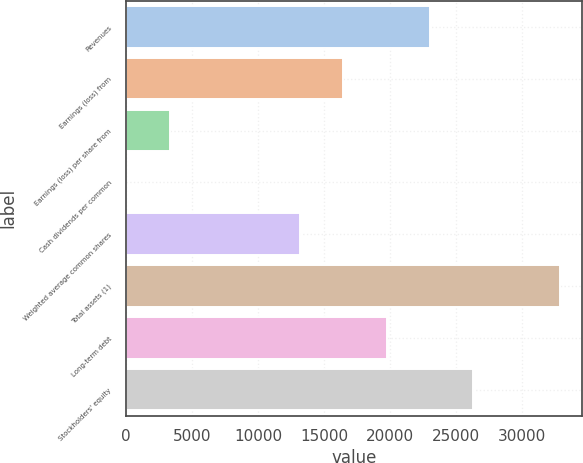Convert chart to OTSL. <chart><loc_0><loc_0><loc_500><loc_500><bar_chart><fcel>Revenues<fcel>Earnings (loss) from<fcel>Earnings (loss) per share from<fcel>Cash dividends per common<fcel>Weighted average common shares<fcel>Total assets (1)<fcel>Long-term debt<fcel>Stockholders' equity<nl><fcel>23049.1<fcel>16463.8<fcel>3293.28<fcel>0.64<fcel>13171.2<fcel>32927<fcel>19756.5<fcel>26341.8<nl></chart> 